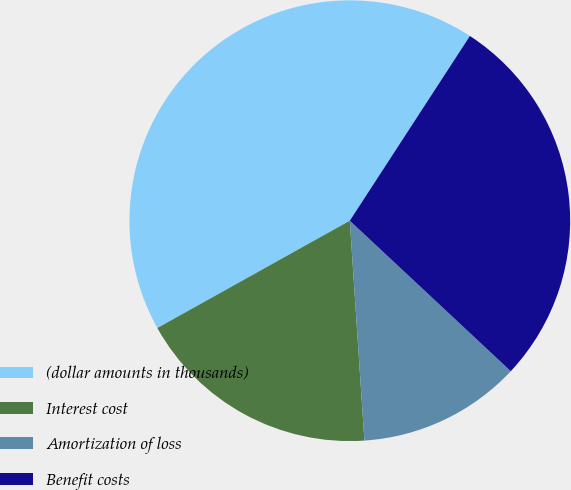<chart> <loc_0><loc_0><loc_500><loc_500><pie_chart><fcel>(dollar amounts in thousands)<fcel>Interest cost<fcel>Amortization of loss<fcel>Benefit costs<nl><fcel>42.27%<fcel>17.96%<fcel>11.98%<fcel>27.79%<nl></chart> 